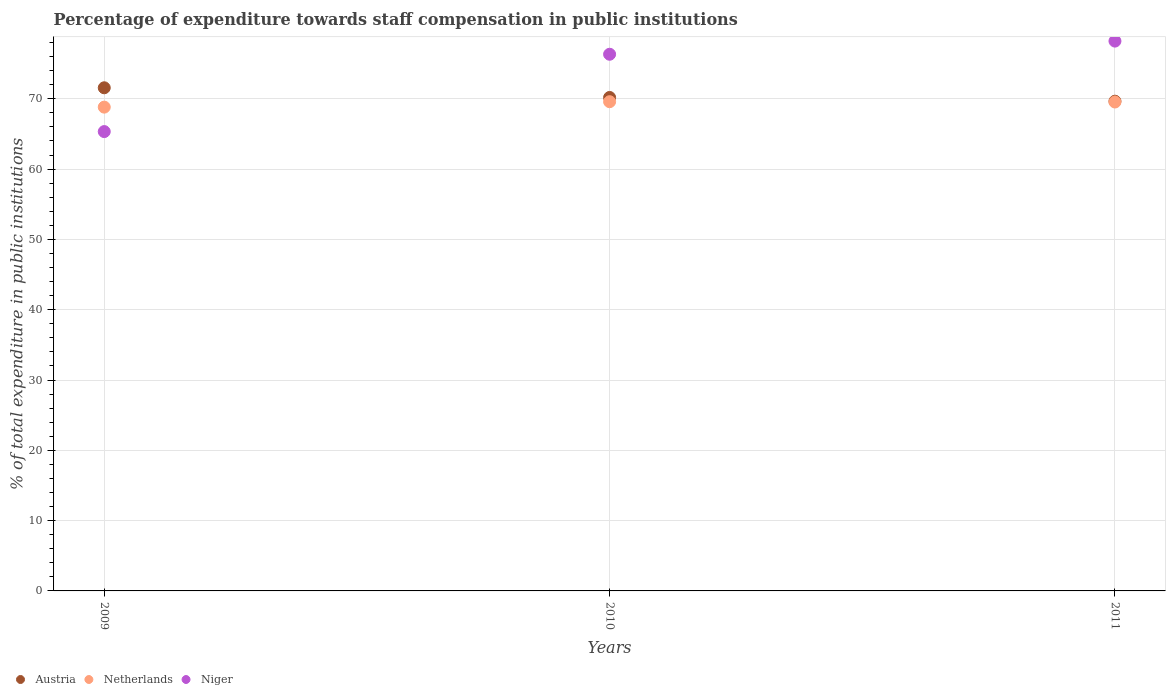What is the percentage of expenditure towards staff compensation in Austria in 2011?
Ensure brevity in your answer.  69.66. Across all years, what is the maximum percentage of expenditure towards staff compensation in Austria?
Give a very brief answer. 71.57. Across all years, what is the minimum percentage of expenditure towards staff compensation in Austria?
Offer a very short reply. 69.66. In which year was the percentage of expenditure towards staff compensation in Niger maximum?
Ensure brevity in your answer.  2011. What is the total percentage of expenditure towards staff compensation in Netherlands in the graph?
Make the answer very short. 207.96. What is the difference between the percentage of expenditure towards staff compensation in Netherlands in 2009 and that in 2011?
Offer a terse response. -0.73. What is the difference between the percentage of expenditure towards staff compensation in Austria in 2010 and the percentage of expenditure towards staff compensation in Niger in 2009?
Provide a succinct answer. 4.85. What is the average percentage of expenditure towards staff compensation in Niger per year?
Make the answer very short. 73.3. In the year 2009, what is the difference between the percentage of expenditure towards staff compensation in Niger and percentage of expenditure towards staff compensation in Netherlands?
Provide a succinct answer. -3.48. In how many years, is the percentage of expenditure towards staff compensation in Niger greater than 50 %?
Your response must be concise. 3. What is the ratio of the percentage of expenditure towards staff compensation in Netherlands in 2009 to that in 2011?
Provide a succinct answer. 0.99. Is the percentage of expenditure towards staff compensation in Austria in 2009 less than that in 2011?
Give a very brief answer. No. What is the difference between the highest and the second highest percentage of expenditure towards staff compensation in Austria?
Your answer should be compact. 1.38. What is the difference between the highest and the lowest percentage of expenditure towards staff compensation in Austria?
Your answer should be compact. 1.91. In how many years, is the percentage of expenditure towards staff compensation in Niger greater than the average percentage of expenditure towards staff compensation in Niger taken over all years?
Ensure brevity in your answer.  2. Is it the case that in every year, the sum of the percentage of expenditure towards staff compensation in Austria and percentage of expenditure towards staff compensation in Netherlands  is greater than the percentage of expenditure towards staff compensation in Niger?
Ensure brevity in your answer.  Yes. Is the percentage of expenditure towards staff compensation in Netherlands strictly greater than the percentage of expenditure towards staff compensation in Austria over the years?
Provide a short and direct response. No. Is the percentage of expenditure towards staff compensation in Netherlands strictly less than the percentage of expenditure towards staff compensation in Niger over the years?
Offer a terse response. No. What is the difference between two consecutive major ticks on the Y-axis?
Give a very brief answer. 10. Are the values on the major ticks of Y-axis written in scientific E-notation?
Your answer should be very brief. No. Does the graph contain any zero values?
Provide a succinct answer. No. Does the graph contain grids?
Offer a terse response. Yes. Where does the legend appear in the graph?
Your response must be concise. Bottom left. How many legend labels are there?
Provide a short and direct response. 3. How are the legend labels stacked?
Offer a very short reply. Horizontal. What is the title of the graph?
Your answer should be compact. Percentage of expenditure towards staff compensation in public institutions. Does "Timor-Leste" appear as one of the legend labels in the graph?
Offer a terse response. No. What is the label or title of the Y-axis?
Ensure brevity in your answer.  % of total expenditure in public institutions. What is the % of total expenditure in public institutions of Austria in 2009?
Offer a very short reply. 71.57. What is the % of total expenditure in public institutions in Netherlands in 2009?
Keep it short and to the point. 68.82. What is the % of total expenditure in public institutions in Niger in 2009?
Ensure brevity in your answer.  65.34. What is the % of total expenditure in public institutions in Austria in 2010?
Give a very brief answer. 70.19. What is the % of total expenditure in public institutions in Netherlands in 2010?
Provide a short and direct response. 69.59. What is the % of total expenditure in public institutions of Niger in 2010?
Give a very brief answer. 76.34. What is the % of total expenditure in public institutions of Austria in 2011?
Ensure brevity in your answer.  69.66. What is the % of total expenditure in public institutions of Netherlands in 2011?
Offer a terse response. 69.55. What is the % of total expenditure in public institutions of Niger in 2011?
Make the answer very short. 78.21. Across all years, what is the maximum % of total expenditure in public institutions of Austria?
Provide a short and direct response. 71.57. Across all years, what is the maximum % of total expenditure in public institutions in Netherlands?
Offer a very short reply. 69.59. Across all years, what is the maximum % of total expenditure in public institutions of Niger?
Offer a very short reply. 78.21. Across all years, what is the minimum % of total expenditure in public institutions of Austria?
Your response must be concise. 69.66. Across all years, what is the minimum % of total expenditure in public institutions in Netherlands?
Your response must be concise. 68.82. Across all years, what is the minimum % of total expenditure in public institutions in Niger?
Keep it short and to the point. 65.34. What is the total % of total expenditure in public institutions in Austria in the graph?
Your response must be concise. 211.42. What is the total % of total expenditure in public institutions of Netherlands in the graph?
Give a very brief answer. 207.96. What is the total % of total expenditure in public institutions in Niger in the graph?
Your response must be concise. 219.89. What is the difference between the % of total expenditure in public institutions in Austria in 2009 and that in 2010?
Provide a short and direct response. 1.38. What is the difference between the % of total expenditure in public institutions of Netherlands in 2009 and that in 2010?
Make the answer very short. -0.77. What is the difference between the % of total expenditure in public institutions of Niger in 2009 and that in 2010?
Your response must be concise. -11. What is the difference between the % of total expenditure in public institutions in Austria in 2009 and that in 2011?
Provide a short and direct response. 1.91. What is the difference between the % of total expenditure in public institutions in Netherlands in 2009 and that in 2011?
Ensure brevity in your answer.  -0.73. What is the difference between the % of total expenditure in public institutions of Niger in 2009 and that in 2011?
Make the answer very short. -12.87. What is the difference between the % of total expenditure in public institutions of Austria in 2010 and that in 2011?
Give a very brief answer. 0.53. What is the difference between the % of total expenditure in public institutions of Netherlands in 2010 and that in 2011?
Provide a succinct answer. 0.04. What is the difference between the % of total expenditure in public institutions in Niger in 2010 and that in 2011?
Provide a succinct answer. -1.87. What is the difference between the % of total expenditure in public institutions of Austria in 2009 and the % of total expenditure in public institutions of Netherlands in 2010?
Your response must be concise. 1.98. What is the difference between the % of total expenditure in public institutions in Austria in 2009 and the % of total expenditure in public institutions in Niger in 2010?
Give a very brief answer. -4.77. What is the difference between the % of total expenditure in public institutions of Netherlands in 2009 and the % of total expenditure in public institutions of Niger in 2010?
Offer a terse response. -7.52. What is the difference between the % of total expenditure in public institutions of Austria in 2009 and the % of total expenditure in public institutions of Netherlands in 2011?
Ensure brevity in your answer.  2.02. What is the difference between the % of total expenditure in public institutions of Austria in 2009 and the % of total expenditure in public institutions of Niger in 2011?
Your response must be concise. -6.64. What is the difference between the % of total expenditure in public institutions of Netherlands in 2009 and the % of total expenditure in public institutions of Niger in 2011?
Offer a very short reply. -9.39. What is the difference between the % of total expenditure in public institutions in Austria in 2010 and the % of total expenditure in public institutions in Netherlands in 2011?
Provide a succinct answer. 0.65. What is the difference between the % of total expenditure in public institutions in Austria in 2010 and the % of total expenditure in public institutions in Niger in 2011?
Ensure brevity in your answer.  -8.02. What is the difference between the % of total expenditure in public institutions in Netherlands in 2010 and the % of total expenditure in public institutions in Niger in 2011?
Provide a short and direct response. -8.62. What is the average % of total expenditure in public institutions of Austria per year?
Provide a short and direct response. 70.47. What is the average % of total expenditure in public institutions of Netherlands per year?
Offer a terse response. 69.32. What is the average % of total expenditure in public institutions in Niger per year?
Your answer should be compact. 73.3. In the year 2009, what is the difference between the % of total expenditure in public institutions in Austria and % of total expenditure in public institutions in Netherlands?
Make the answer very short. 2.75. In the year 2009, what is the difference between the % of total expenditure in public institutions in Austria and % of total expenditure in public institutions in Niger?
Provide a short and direct response. 6.23. In the year 2009, what is the difference between the % of total expenditure in public institutions of Netherlands and % of total expenditure in public institutions of Niger?
Your answer should be very brief. 3.48. In the year 2010, what is the difference between the % of total expenditure in public institutions in Austria and % of total expenditure in public institutions in Netherlands?
Your response must be concise. 0.6. In the year 2010, what is the difference between the % of total expenditure in public institutions in Austria and % of total expenditure in public institutions in Niger?
Ensure brevity in your answer.  -6.15. In the year 2010, what is the difference between the % of total expenditure in public institutions of Netherlands and % of total expenditure in public institutions of Niger?
Keep it short and to the point. -6.75. In the year 2011, what is the difference between the % of total expenditure in public institutions in Austria and % of total expenditure in public institutions in Netherlands?
Your answer should be very brief. 0.11. In the year 2011, what is the difference between the % of total expenditure in public institutions in Austria and % of total expenditure in public institutions in Niger?
Keep it short and to the point. -8.55. In the year 2011, what is the difference between the % of total expenditure in public institutions of Netherlands and % of total expenditure in public institutions of Niger?
Your response must be concise. -8.66. What is the ratio of the % of total expenditure in public institutions in Austria in 2009 to that in 2010?
Keep it short and to the point. 1.02. What is the ratio of the % of total expenditure in public institutions in Netherlands in 2009 to that in 2010?
Your answer should be compact. 0.99. What is the ratio of the % of total expenditure in public institutions in Niger in 2009 to that in 2010?
Give a very brief answer. 0.86. What is the ratio of the % of total expenditure in public institutions of Austria in 2009 to that in 2011?
Your response must be concise. 1.03. What is the ratio of the % of total expenditure in public institutions of Niger in 2009 to that in 2011?
Your response must be concise. 0.84. What is the ratio of the % of total expenditure in public institutions in Austria in 2010 to that in 2011?
Provide a succinct answer. 1.01. What is the ratio of the % of total expenditure in public institutions of Niger in 2010 to that in 2011?
Your response must be concise. 0.98. What is the difference between the highest and the second highest % of total expenditure in public institutions of Austria?
Give a very brief answer. 1.38. What is the difference between the highest and the second highest % of total expenditure in public institutions of Netherlands?
Offer a very short reply. 0.04. What is the difference between the highest and the second highest % of total expenditure in public institutions in Niger?
Provide a short and direct response. 1.87. What is the difference between the highest and the lowest % of total expenditure in public institutions in Austria?
Make the answer very short. 1.91. What is the difference between the highest and the lowest % of total expenditure in public institutions in Netherlands?
Provide a short and direct response. 0.77. What is the difference between the highest and the lowest % of total expenditure in public institutions of Niger?
Keep it short and to the point. 12.87. 